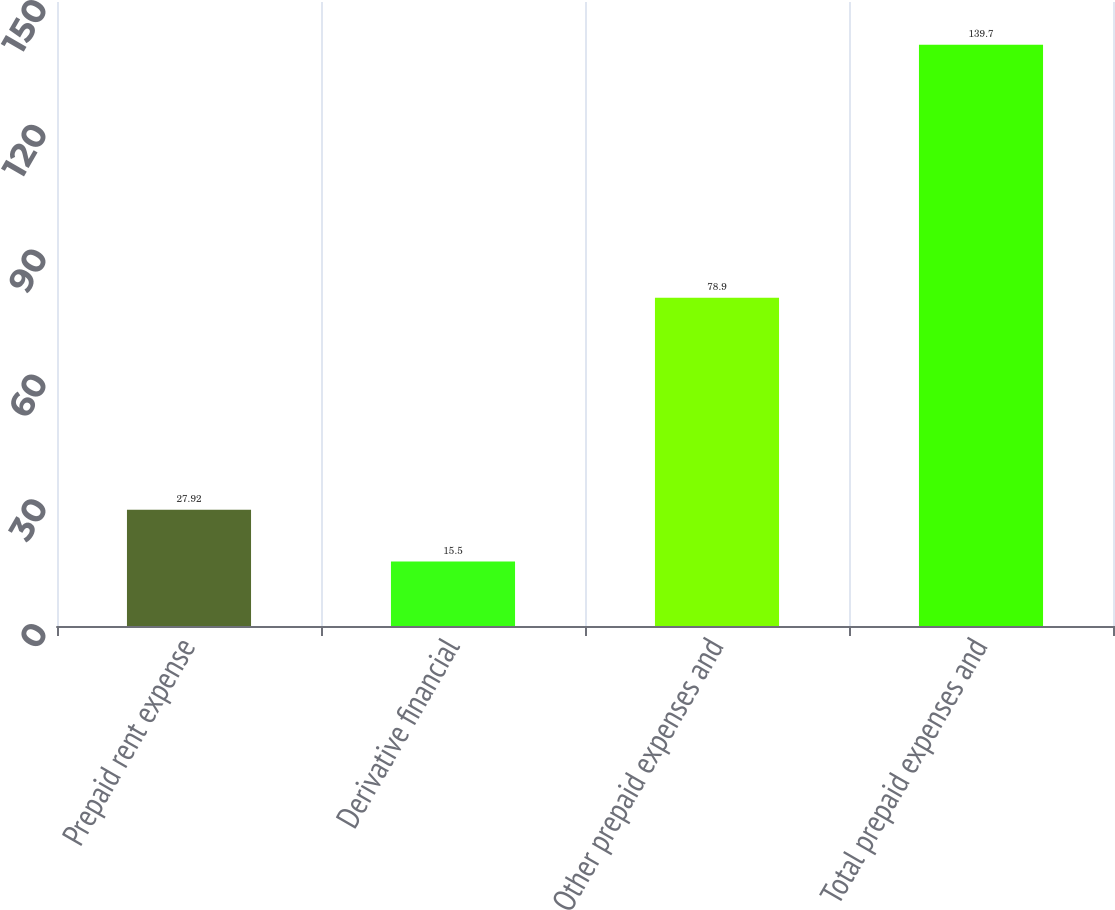Convert chart to OTSL. <chart><loc_0><loc_0><loc_500><loc_500><bar_chart><fcel>Prepaid rent expense<fcel>Derivative financial<fcel>Other prepaid expenses and<fcel>Total prepaid expenses and<nl><fcel>27.92<fcel>15.5<fcel>78.9<fcel>139.7<nl></chart> 